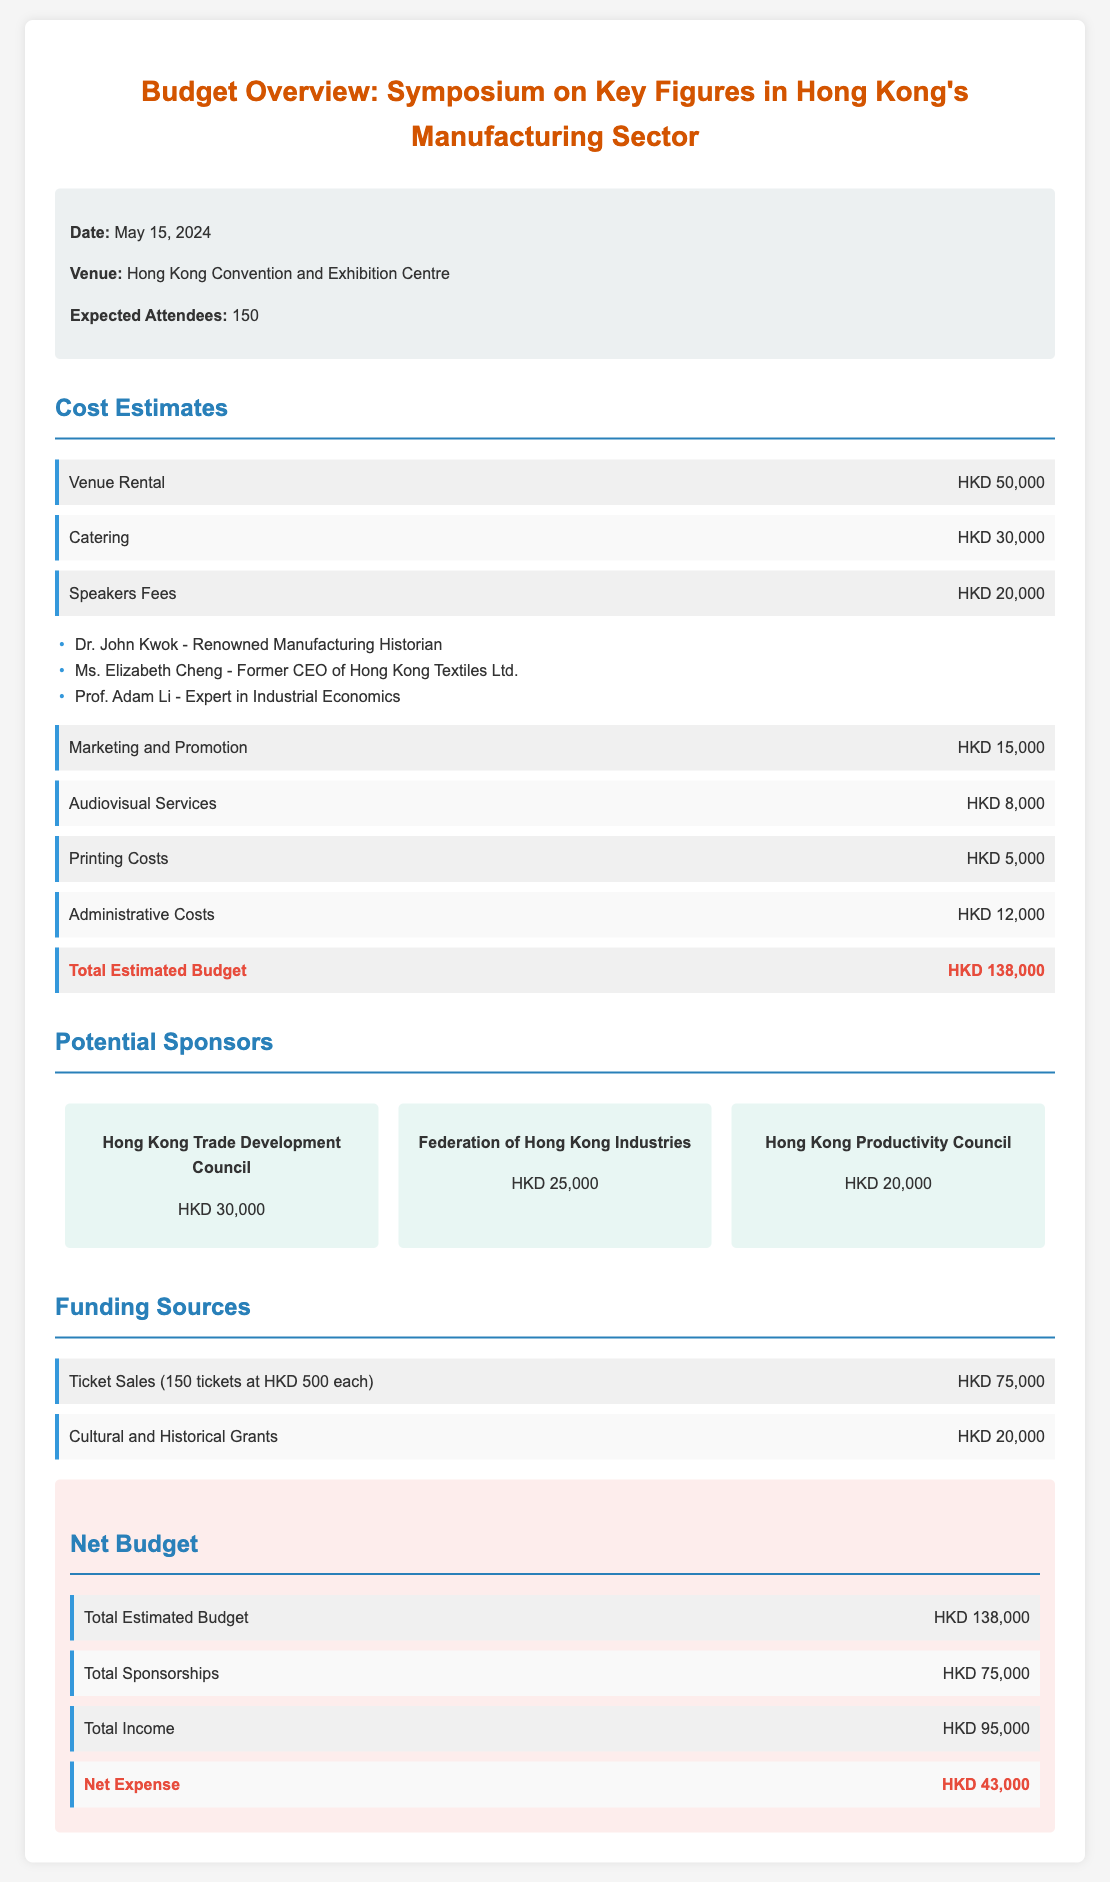What is the date of the symposium? The document states that the symposium is scheduled for May 15, 2024.
Answer: May 15, 2024 What is the venue for the event? According to the document, the symposium will be held at the Hong Kong Convention and Exhibition Centre.
Answer: Hong Kong Convention and Exhibition Centre How many expected attendees are there? The document mentions that there are expected 150 attendees for the symposium.
Answer: 150 What is the total estimated budget? The total estimated budget is provided in the document as HKD 138,000.
Answer: HKD 138,000 Who is the first speaker listed? The document lists Dr. John Kwok as the first speaker among the speakers in the symposium.
Answer: Dr. John Kwok What is the sponsorship amount from the Hong Kong Trade Development Council? The document specifies that the Hong Kong Trade Development Council is sponsoring HKD 30,000.
Answer: HKD 30,000 What is the total income listed from ticket sales? The total income from ticket sales is calculated as HKD 75,000 in the document.
Answer: HKD 75,000 What are the administrative costs? The document indicates that the administrative costs amount to HKD 12,000.
Answer: HKD 12,000 What is the net expense for the symposium? The net expense calculated in the document is HKD 43,000.
Answer: HKD 43,000 